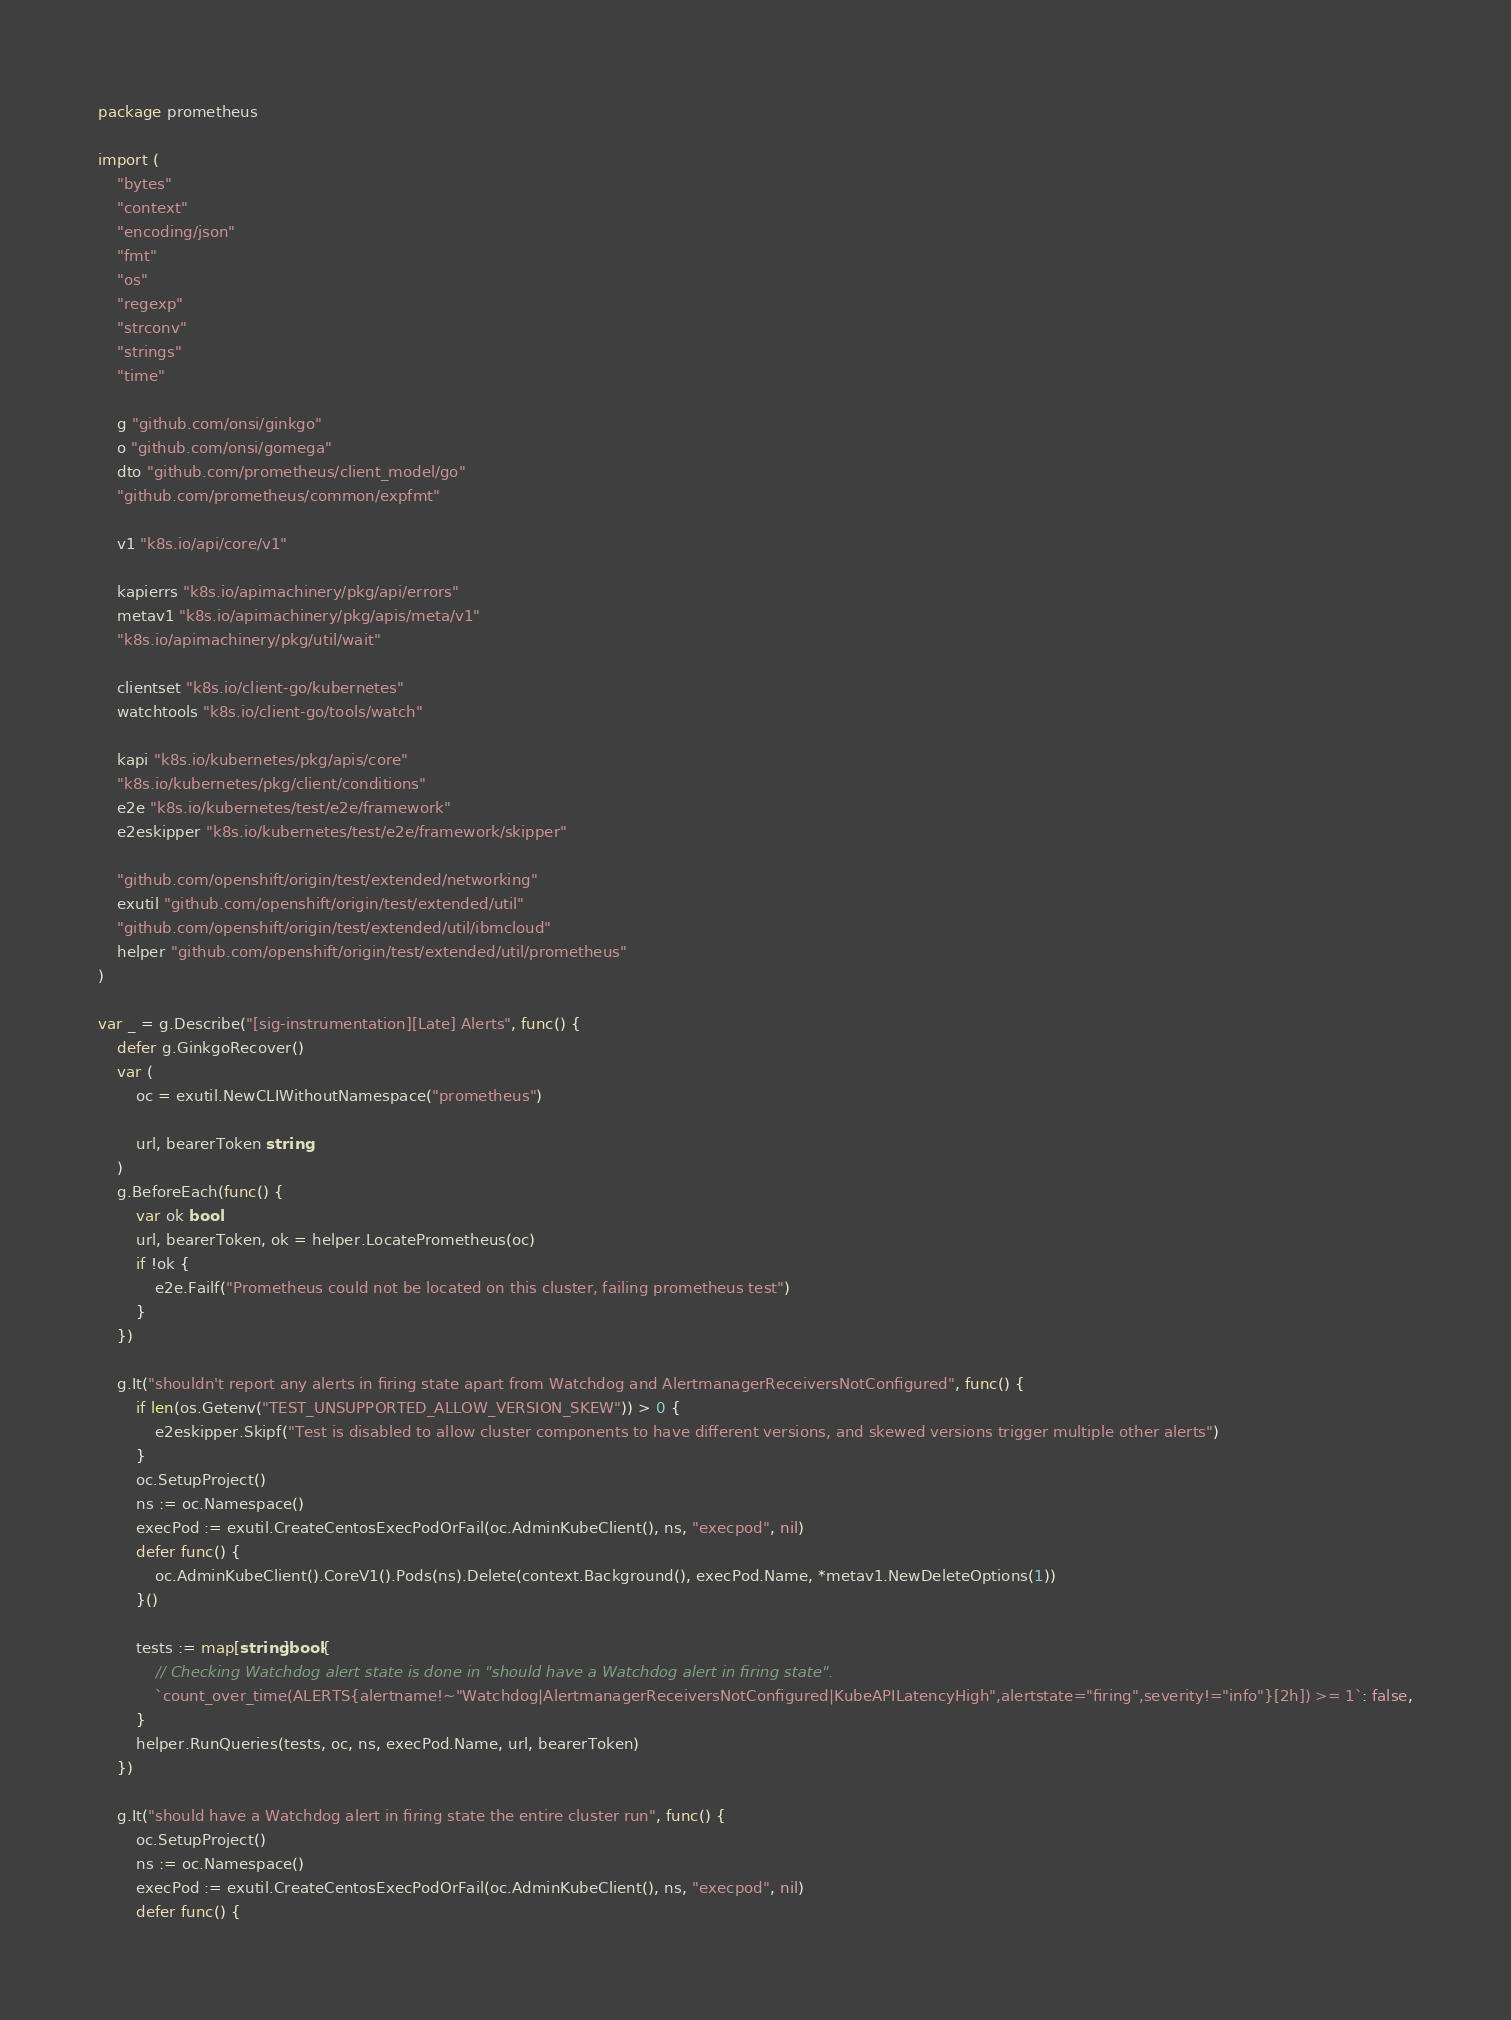Convert code to text. <code><loc_0><loc_0><loc_500><loc_500><_Go_>package prometheus

import (
	"bytes"
	"context"
	"encoding/json"
	"fmt"
	"os"
	"regexp"
	"strconv"
	"strings"
	"time"

	g "github.com/onsi/ginkgo"
	o "github.com/onsi/gomega"
	dto "github.com/prometheus/client_model/go"
	"github.com/prometheus/common/expfmt"

	v1 "k8s.io/api/core/v1"

	kapierrs "k8s.io/apimachinery/pkg/api/errors"
	metav1 "k8s.io/apimachinery/pkg/apis/meta/v1"
	"k8s.io/apimachinery/pkg/util/wait"

	clientset "k8s.io/client-go/kubernetes"
	watchtools "k8s.io/client-go/tools/watch"

	kapi "k8s.io/kubernetes/pkg/apis/core"
	"k8s.io/kubernetes/pkg/client/conditions"
	e2e "k8s.io/kubernetes/test/e2e/framework"
	e2eskipper "k8s.io/kubernetes/test/e2e/framework/skipper"

	"github.com/openshift/origin/test/extended/networking"
	exutil "github.com/openshift/origin/test/extended/util"
	"github.com/openshift/origin/test/extended/util/ibmcloud"
	helper "github.com/openshift/origin/test/extended/util/prometheus"
)

var _ = g.Describe("[sig-instrumentation][Late] Alerts", func() {
	defer g.GinkgoRecover()
	var (
		oc = exutil.NewCLIWithoutNamespace("prometheus")

		url, bearerToken string
	)
	g.BeforeEach(func() {
		var ok bool
		url, bearerToken, ok = helper.LocatePrometheus(oc)
		if !ok {
			e2e.Failf("Prometheus could not be located on this cluster, failing prometheus test")
		}
	})

	g.It("shouldn't report any alerts in firing state apart from Watchdog and AlertmanagerReceiversNotConfigured", func() {
		if len(os.Getenv("TEST_UNSUPPORTED_ALLOW_VERSION_SKEW")) > 0 {
			e2eskipper.Skipf("Test is disabled to allow cluster components to have different versions, and skewed versions trigger multiple other alerts")
		}
		oc.SetupProject()
		ns := oc.Namespace()
		execPod := exutil.CreateCentosExecPodOrFail(oc.AdminKubeClient(), ns, "execpod", nil)
		defer func() {
			oc.AdminKubeClient().CoreV1().Pods(ns).Delete(context.Background(), execPod.Name, *metav1.NewDeleteOptions(1))
		}()

		tests := map[string]bool{
			// Checking Watchdog alert state is done in "should have a Watchdog alert in firing state".
			`count_over_time(ALERTS{alertname!~"Watchdog|AlertmanagerReceiversNotConfigured|KubeAPILatencyHigh",alertstate="firing",severity!="info"}[2h]) >= 1`: false,
		}
		helper.RunQueries(tests, oc, ns, execPod.Name, url, bearerToken)
	})

	g.It("should have a Watchdog alert in firing state the entire cluster run", func() {
		oc.SetupProject()
		ns := oc.Namespace()
		execPod := exutil.CreateCentosExecPodOrFail(oc.AdminKubeClient(), ns, "execpod", nil)
		defer func() {</code> 